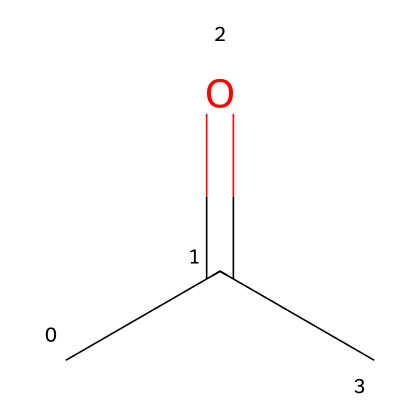What is the common name for the SMILES representation CC(=O)C? The SMILES representation indicates a molecule with a carbonyl group (C=O) and an aliphatic structure. This corresponds to acetone, which is the common name for this compound.
Answer: acetone How many carbon atoms are present in the structure of acetone? The SMILES notation CC(=O)C shows three carbon atoms in total; two from the 'CC' and one from the terminal carbon.
Answer: 3 How many oxygen atoms are there in the structure? In the SMILES representation, the '=O' notation indicates one oxygen atom connected by a double bond to a carbon, hence there is one oxygen atom in acetone.
Answer: 1 What type of functional group is present in acetone? The structure CC(=O)C features a carbonyl group (C=O), which is characteristic of ketones. Therefore, acetone has a ketone functional group.
Answer: ketone Is acetone a saturated or unsaturated compound? The structure CC(=O)C does not have any double bonds between carbon atoms other than the carbonyl group, which means the remaining carbon chain is saturated. Thus, acetone is a saturated compound.
Answer: saturated Why is acetone commonly used as a solvent in electronics manufacturing? Acetone is highly polar and can dissolve a wide range of substances, which is crucial in electronics manufacturing for cleaning and preparing surfaces without residues.
Answer: high polarity and dissolving capability What property makes acetone suitable for use as a solvent? The polarity and the ability to dissolve both polar and non-polar substances make acetone an effective solvent in various applications, especially in electronics.
Answer: polarity 